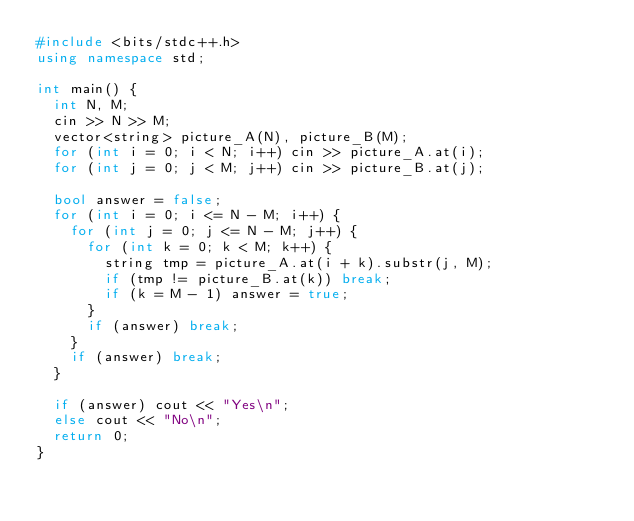Convert code to text. <code><loc_0><loc_0><loc_500><loc_500><_C++_>#include <bits/stdc++.h>
using namespace std;

int main() {
  int N, M;
  cin >> N >> M;
  vector<string> picture_A(N), picture_B(M);
  for (int i = 0; i < N; i++) cin >> picture_A.at(i);
  for (int j = 0; j < M; j++) cin >> picture_B.at(j);
  
  bool answer = false;
  for (int i = 0; i <= N - M; i++) {
    for (int j = 0; j <= N - M; j++) {
      for (int k = 0; k < M; k++) {
        string tmp = picture_A.at(i + k).substr(j, M);
        if (tmp != picture_B.at(k)) break;
        if (k = M - 1) answer = true;
      }
      if (answer) break;
    }
    if (answer) break;
  }
  
  if (answer) cout << "Yes\n";
  else cout << "No\n";
  return 0;
}
</code> 